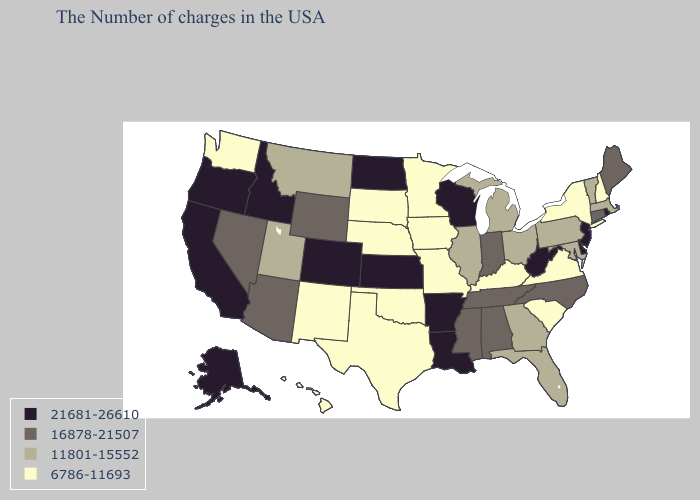Name the states that have a value in the range 16878-21507?
Be succinct. Maine, Connecticut, North Carolina, Indiana, Alabama, Tennessee, Mississippi, Wyoming, Arizona, Nevada. Does South Dakota have the highest value in the USA?
Keep it brief. No. What is the value of Arizona?
Keep it brief. 16878-21507. Name the states that have a value in the range 6786-11693?
Write a very short answer. New Hampshire, New York, Virginia, South Carolina, Kentucky, Missouri, Minnesota, Iowa, Nebraska, Oklahoma, Texas, South Dakota, New Mexico, Washington, Hawaii. Name the states that have a value in the range 6786-11693?
Give a very brief answer. New Hampshire, New York, Virginia, South Carolina, Kentucky, Missouri, Minnesota, Iowa, Nebraska, Oklahoma, Texas, South Dakota, New Mexico, Washington, Hawaii. What is the value of Nebraska?
Short answer required. 6786-11693. What is the value of Nevada?
Concise answer only. 16878-21507. What is the value of Washington?
Short answer required. 6786-11693. Name the states that have a value in the range 6786-11693?
Answer briefly. New Hampshire, New York, Virginia, South Carolina, Kentucky, Missouri, Minnesota, Iowa, Nebraska, Oklahoma, Texas, South Dakota, New Mexico, Washington, Hawaii. Name the states that have a value in the range 16878-21507?
Keep it brief. Maine, Connecticut, North Carolina, Indiana, Alabama, Tennessee, Mississippi, Wyoming, Arizona, Nevada. Name the states that have a value in the range 21681-26610?
Keep it brief. Rhode Island, New Jersey, Delaware, West Virginia, Wisconsin, Louisiana, Arkansas, Kansas, North Dakota, Colorado, Idaho, California, Oregon, Alaska. Name the states that have a value in the range 21681-26610?
Quick response, please. Rhode Island, New Jersey, Delaware, West Virginia, Wisconsin, Louisiana, Arkansas, Kansas, North Dakota, Colorado, Idaho, California, Oregon, Alaska. Which states have the highest value in the USA?
Keep it brief. Rhode Island, New Jersey, Delaware, West Virginia, Wisconsin, Louisiana, Arkansas, Kansas, North Dakota, Colorado, Idaho, California, Oregon, Alaska. Which states have the lowest value in the USA?
Keep it brief. New Hampshire, New York, Virginia, South Carolina, Kentucky, Missouri, Minnesota, Iowa, Nebraska, Oklahoma, Texas, South Dakota, New Mexico, Washington, Hawaii. Does Nevada have a lower value than North Dakota?
Concise answer only. Yes. 